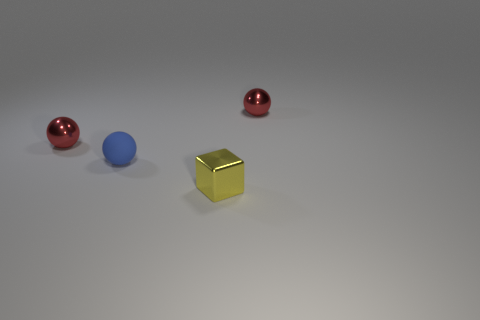There is a small red thing to the left of the blue sphere; is its shape the same as the tiny red object to the right of the small blue matte sphere?
Provide a short and direct response. Yes. What number of things are small matte cylinders or metallic objects on the left side of the blue rubber sphere?
Keep it short and to the point. 1. There is a tiny thing that is behind the matte ball and on the left side of the yellow metal cube; what is its material?
Ensure brevity in your answer.  Metal. What is the blue object that is on the left side of the yellow metallic object made of?
Your answer should be compact. Rubber. There is a blue matte object; is its shape the same as the metal thing that is right of the small block?
Make the answer very short. Yes. There is a rubber object; are there any red metal things right of it?
Ensure brevity in your answer.  Yes. There is a yellow cube; is its size the same as the metal ball that is on the left side of the blue ball?
Ensure brevity in your answer.  Yes. Is there a ball of the same color as the matte thing?
Your response must be concise. No. Are there any red metallic things of the same shape as the blue thing?
Keep it short and to the point. Yes. There is a small thing that is both behind the blue rubber sphere and to the left of the yellow thing; what shape is it?
Provide a succinct answer. Sphere. 